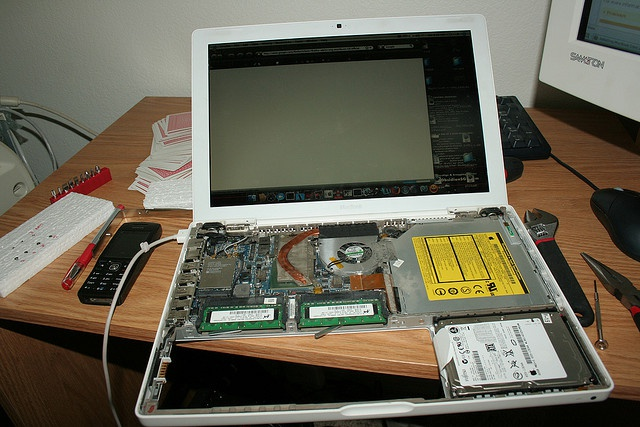Describe the objects in this image and their specific colors. I can see laptop in gray, black, lightgray, and darkgray tones, tv in gray, darkgray, black, and purple tones, cell phone in gray, black, and darkgray tones, mouse in gray, black, and maroon tones, and keyboard in gray, black, maroon, and darkgray tones in this image. 